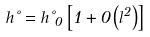Convert formula to latex. <formula><loc_0><loc_0><loc_500><loc_500>h \nu = h \nu _ { 0 } \left [ 1 + 0 \left ( l ^ { 2 } \right ) \right ]</formula> 